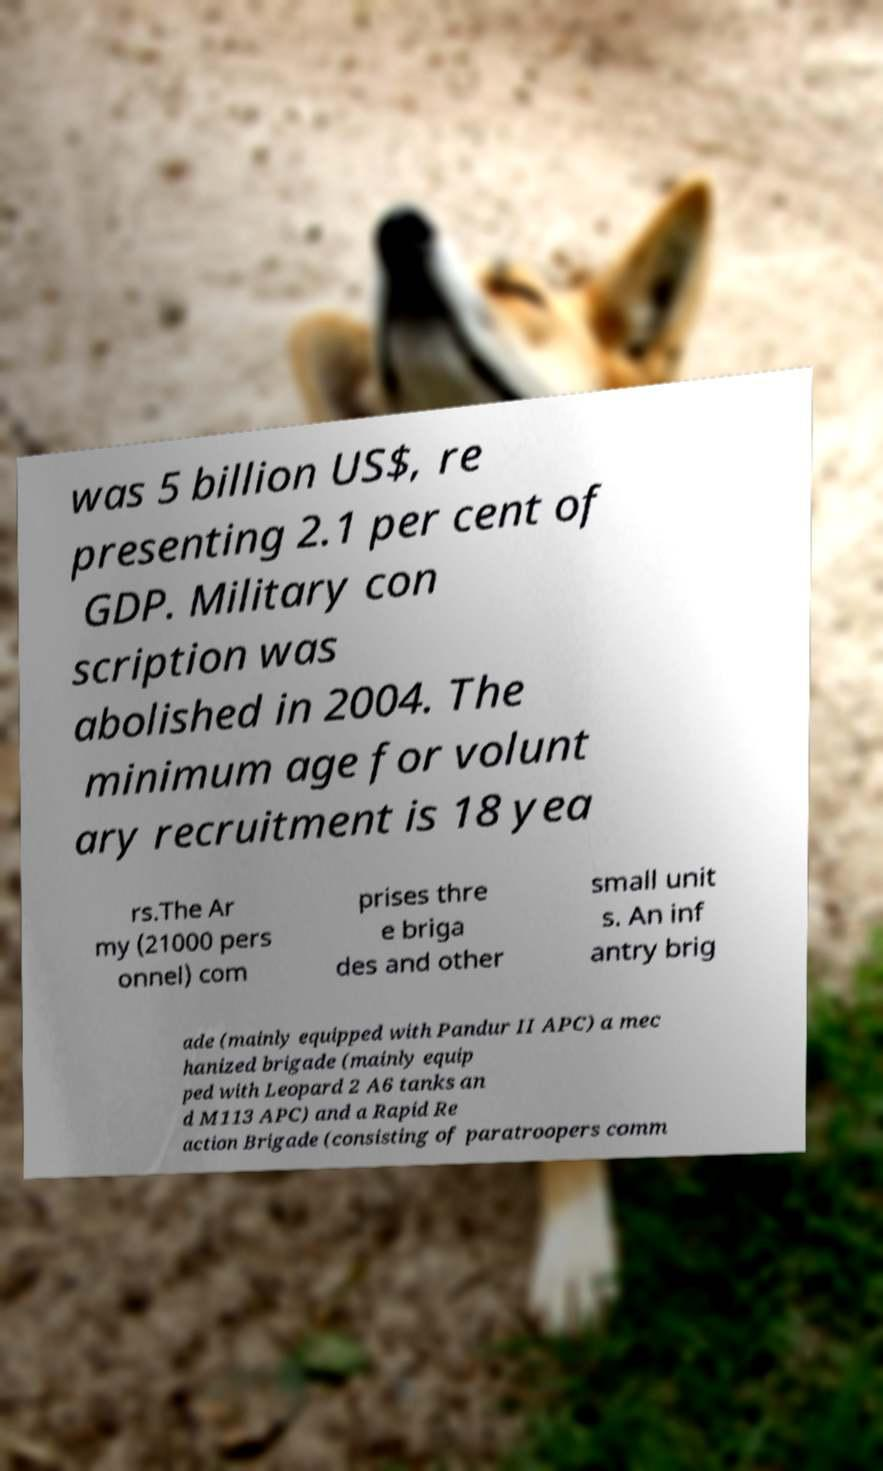For documentation purposes, I need the text within this image transcribed. Could you provide that? was 5 billion US$, re presenting 2.1 per cent of GDP. Military con scription was abolished in 2004. The minimum age for volunt ary recruitment is 18 yea rs.The Ar my (21000 pers onnel) com prises thre e briga des and other small unit s. An inf antry brig ade (mainly equipped with Pandur II APC) a mec hanized brigade (mainly equip ped with Leopard 2 A6 tanks an d M113 APC) and a Rapid Re action Brigade (consisting of paratroopers comm 